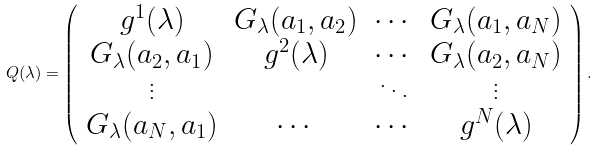<formula> <loc_0><loc_0><loc_500><loc_500>Q ( \lambda ) = \left ( \begin{array} { c c c c } g ^ { 1 } ( \lambda ) & G _ { \lambda } ( a _ { 1 } , a _ { 2 } ) & \cdots & G _ { \lambda } ( a _ { 1 } , a _ { N } ) \\ G _ { \lambda } ( a _ { 2 } , a _ { 1 } ) & g ^ { 2 } ( \lambda ) & \cdots & G _ { \lambda } ( a _ { 2 } , a _ { N } ) \\ \vdots & & \ddots & \vdots \\ G _ { \lambda } ( a _ { N } , a _ { 1 } ) & \cdots & \cdots & g ^ { N } ( \lambda ) \end{array} \right ) .</formula> 